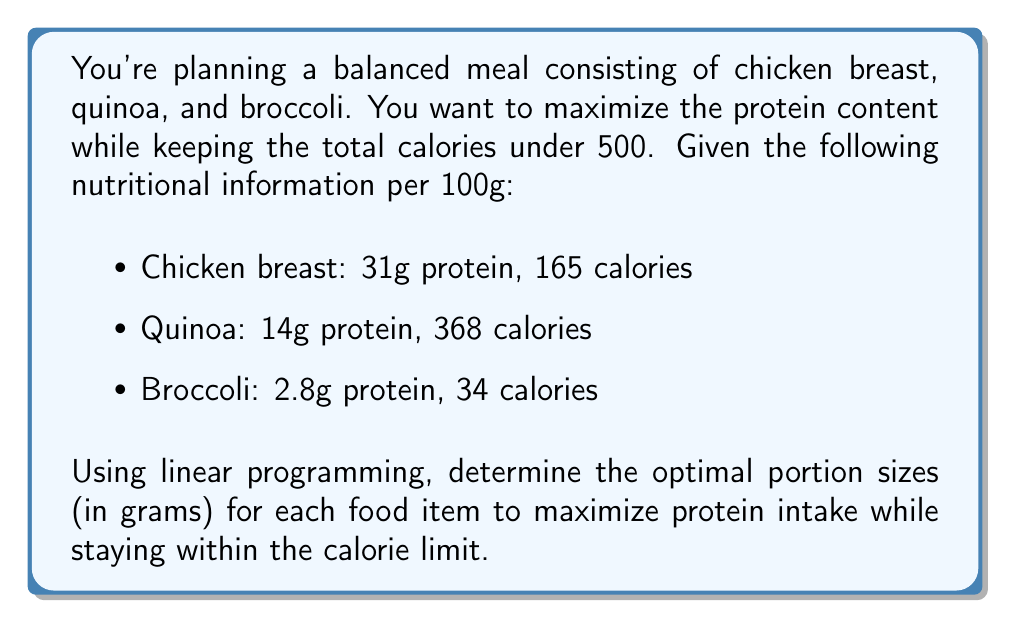Show me your answer to this math problem. Let's approach this step-by-step using linear programming:

1. Define variables:
   Let $x$ = grams of chicken breast
   Let $y$ = grams of quinoa
   Let $z$ = grams of broccoli

2. Objective function (maximize protein):
   $$\text{Maximize } P = 0.31x + 0.14y + 0.028z$$

3. Constraints:
   Calorie constraint: $1.65x + 3.68y + 0.34z \leq 500$
   Non-negativity: $x, y, z \geq 0$

4. Set up the linear program:
   $$\begin{array}{ll}
   \text{Maximize} & P = 0.31x + 0.14y + 0.028z \\
   \text{Subject to:} & 1.65x + 3.68y + 0.34z \leq 500 \\
   & x, y, z \geq 0
   \end{array}$$

5. Solve using the simplex method or a linear programming solver:
   The optimal solution is:
   $x = 303.03$ g of chicken breast
   $y = 0$ g of quinoa
   $z = 0$ g of broccoli

6. Verify the solution:
   Protein: $0.31 * 303.03 = 93.94$ g
   Calories: $1.65 * 303.03 = 500$ calories

The optimal solution suggests focusing entirely on chicken breast to maximize protein while staying within the calorie limit. However, this may not be the most balanced meal.

7. Consider adding minimum portion constraints for a more balanced meal:
   Add constraints: $y \geq 50$ and $z \geq 100$

8. Solve the new linear program:
   $$\begin{array}{ll}
   \text{Maximize} & P = 0.31x + 0.14y + 0.028z \\
   \text{Subject to:} & 1.65x + 3.68y + 0.34z \leq 500 \\
   & y \geq 50 \\
   & z \geq 100 \\
   & x, y, z \geq 0
   \end{array}$$

9. The new optimal solution is:
   $x = 212.12$ g of chicken breast
   $y = 50$ g of quinoa
   $z = 100$ g of broccoli

10. Verify the new solution:
    Protein: $0.31 * 212.12 + 0.14 * 50 + 0.028 * 100 = 72.76$ g
    Calories: $1.65 * 212.12 + 3.68 * 50 + 0.34 * 100 = 500$ calories

This solution provides a more balanced meal while still maximizing protein intake within the calorie limit.
Answer: 212g chicken breast, 50g quinoa, 100g broccoli 